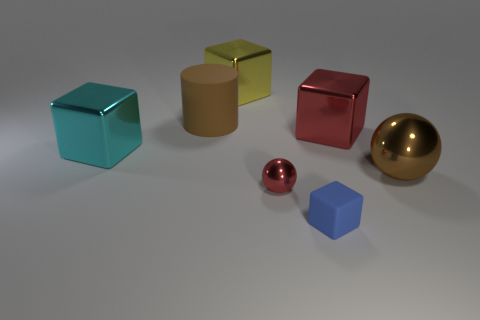What is the size of the other metal thing that is the same color as the tiny metal object?
Give a very brief answer. Large. There is a red block; are there any objects in front of it?
Your response must be concise. Yes. There is a brown object in front of the big rubber cylinder; how many brown balls are in front of it?
Offer a terse response. 0. There is a rubber cylinder; is its size the same as the thing to the left of the big matte thing?
Provide a short and direct response. Yes. Is there another shiny block of the same color as the small cube?
Your answer should be compact. No. The blue thing that is the same material as the big cylinder is what size?
Give a very brief answer. Small. Is the tiny red sphere made of the same material as the cyan block?
Make the answer very short. Yes. There is a ball behind the ball that is in front of the big brown thing in front of the large rubber cylinder; what is its color?
Make the answer very short. Brown. The yellow object is what shape?
Ensure brevity in your answer.  Cube. Is the color of the matte cylinder the same as the metal thing in front of the large brown ball?
Your answer should be compact. No. 